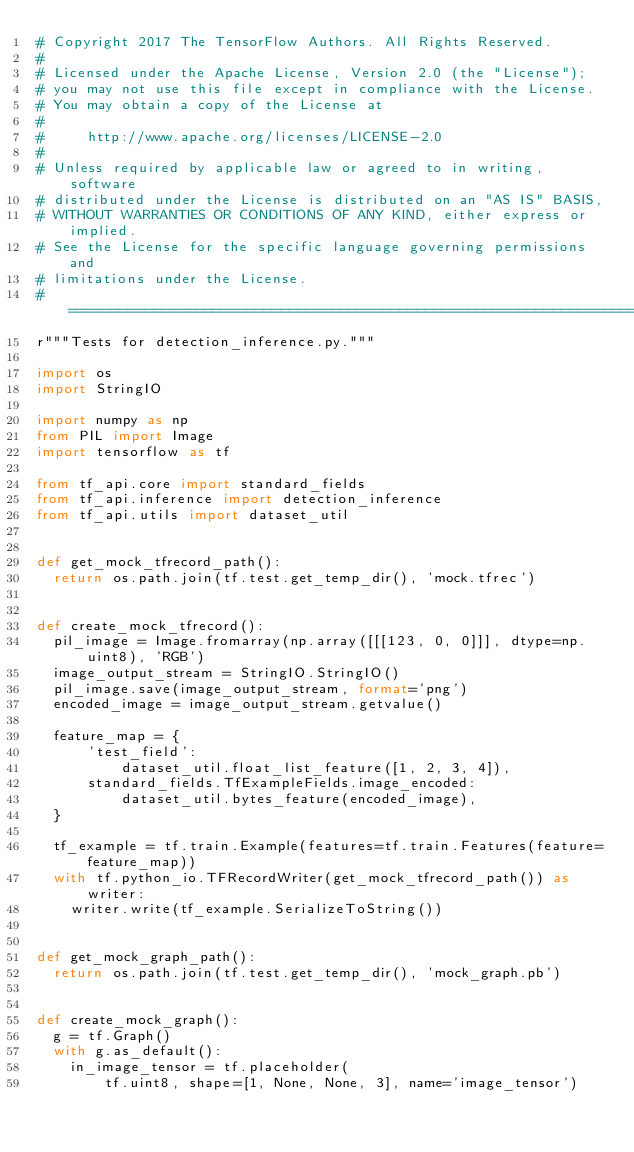Convert code to text. <code><loc_0><loc_0><loc_500><loc_500><_Python_># Copyright 2017 The TensorFlow Authors. All Rights Reserved.
#
# Licensed under the Apache License, Version 2.0 (the "License");
# you may not use this file except in compliance with the License.
# You may obtain a copy of the License at
#
#     http://www.apache.org/licenses/LICENSE-2.0
#
# Unless required by applicable law or agreed to in writing, software
# distributed under the License is distributed on an "AS IS" BASIS,
# WITHOUT WARRANTIES OR CONDITIONS OF ANY KIND, either express or implied.
# See the License for the specific language governing permissions and
# limitations under the License.
# ==============================================================================
r"""Tests for detection_inference.py."""

import os
import StringIO

import numpy as np
from PIL import Image
import tensorflow as tf

from tf_api.core import standard_fields
from tf_api.inference import detection_inference
from tf_api.utils import dataset_util


def get_mock_tfrecord_path():
  return os.path.join(tf.test.get_temp_dir(), 'mock.tfrec')


def create_mock_tfrecord():
  pil_image = Image.fromarray(np.array([[[123, 0, 0]]], dtype=np.uint8), 'RGB')
  image_output_stream = StringIO.StringIO()
  pil_image.save(image_output_stream, format='png')
  encoded_image = image_output_stream.getvalue()

  feature_map = {
      'test_field':
          dataset_util.float_list_feature([1, 2, 3, 4]),
      standard_fields.TfExampleFields.image_encoded:
          dataset_util.bytes_feature(encoded_image),
  }

  tf_example = tf.train.Example(features=tf.train.Features(feature=feature_map))
  with tf.python_io.TFRecordWriter(get_mock_tfrecord_path()) as writer:
    writer.write(tf_example.SerializeToString())


def get_mock_graph_path():
  return os.path.join(tf.test.get_temp_dir(), 'mock_graph.pb')


def create_mock_graph():
  g = tf.Graph()
  with g.as_default():
    in_image_tensor = tf.placeholder(
        tf.uint8, shape=[1, None, None, 3], name='image_tensor')</code> 